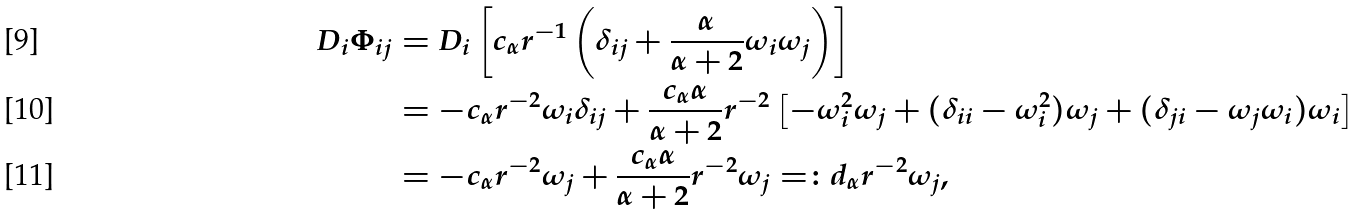Convert formula to latex. <formula><loc_0><loc_0><loc_500><loc_500>D _ { i } \Phi _ { i j } & = D _ { i } \left [ c _ { \alpha } r ^ { - 1 } \left ( \delta _ { i j } + \frac { \alpha } { \alpha + 2 } \omega _ { i } \omega _ { j } \right ) \right ] \\ & = - c _ { \alpha } r ^ { - 2 } \omega _ { i } \delta _ { i j } + \frac { c _ { \alpha } \alpha } { \alpha + 2 } r ^ { - 2 } \left [ - \omega _ { i } ^ { 2 } \omega _ { j } + ( \delta _ { i i } - \omega _ { i } ^ { 2 } ) \omega _ { j } + ( \delta _ { j i } - \omega _ { j } \omega _ { i } ) \omega _ { i } \right ] \\ & = - c _ { \alpha } r ^ { - 2 } \omega _ { j } + \frac { c _ { \alpha } \alpha } { \alpha + 2 } r ^ { - 2 } \omega _ { j } = \colon d _ { \alpha } r ^ { - 2 } \omega _ { j } ,</formula> 